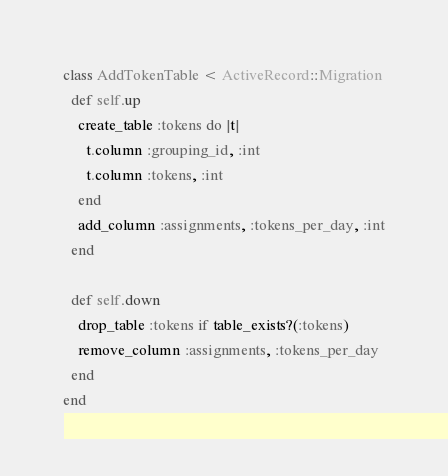Convert code to text. <code><loc_0><loc_0><loc_500><loc_500><_Ruby_>class AddTokenTable < ActiveRecord::Migration
  def self.up
    create_table :tokens do |t|
      t.column :grouping_id, :int
      t.column :tokens, :int
    end
    add_column :assignments, :tokens_per_day, :int
  end

  def self.down
    drop_table :tokens if table_exists?(:tokens)
    remove_column :assignments, :tokens_per_day
  end
end
</code> 